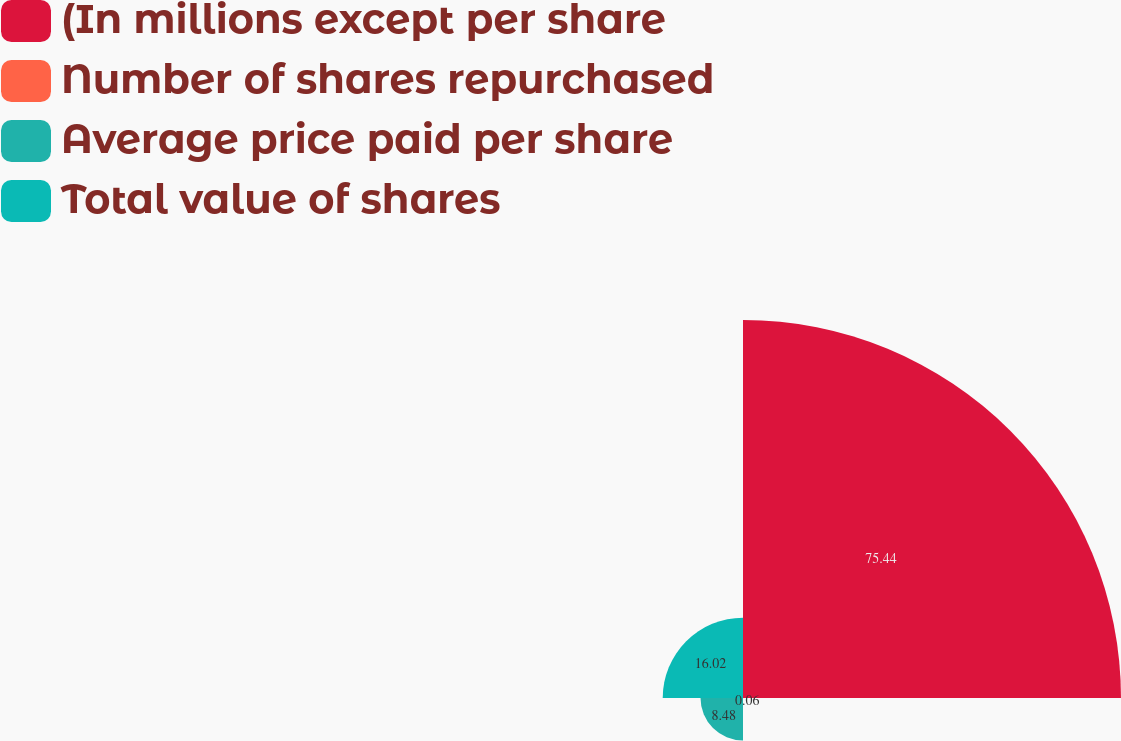Convert chart to OTSL. <chart><loc_0><loc_0><loc_500><loc_500><pie_chart><fcel>(In millions except per share<fcel>Number of shares repurchased<fcel>Average price paid per share<fcel>Total value of shares<nl><fcel>75.44%<fcel>0.06%<fcel>8.48%<fcel>16.02%<nl></chart> 